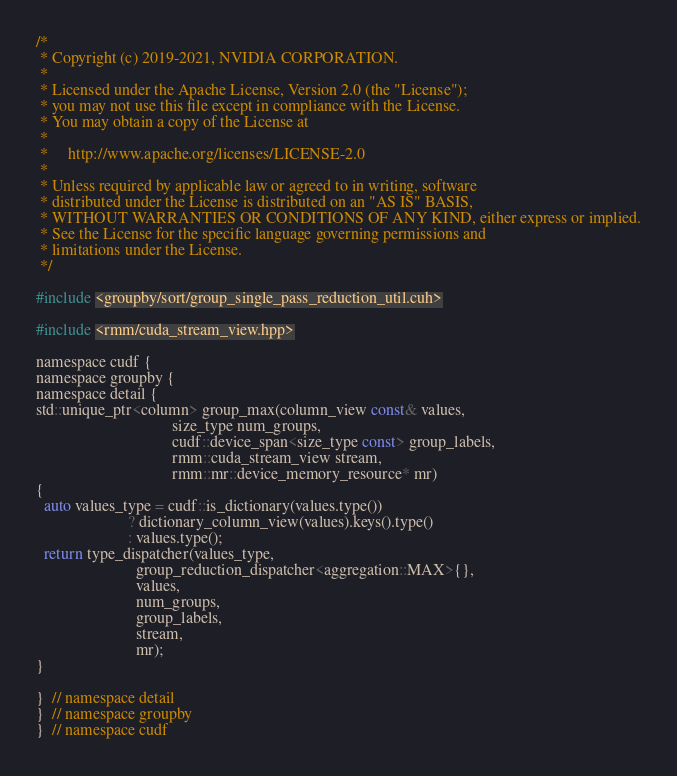Convert code to text. <code><loc_0><loc_0><loc_500><loc_500><_Cuda_>/*
 * Copyright (c) 2019-2021, NVIDIA CORPORATION.
 *
 * Licensed under the Apache License, Version 2.0 (the "License");
 * you may not use this file except in compliance with the License.
 * You may obtain a copy of the License at
 *
 *     http://www.apache.org/licenses/LICENSE-2.0
 *
 * Unless required by applicable law or agreed to in writing, software
 * distributed under the License is distributed on an "AS IS" BASIS,
 * WITHOUT WARRANTIES OR CONDITIONS OF ANY KIND, either express or implied.
 * See the License for the specific language governing permissions and
 * limitations under the License.
 */

#include <groupby/sort/group_single_pass_reduction_util.cuh>

#include <rmm/cuda_stream_view.hpp>

namespace cudf {
namespace groupby {
namespace detail {
std::unique_ptr<column> group_max(column_view const& values,
                                  size_type num_groups,
                                  cudf::device_span<size_type const> group_labels,
                                  rmm::cuda_stream_view stream,
                                  rmm::mr::device_memory_resource* mr)
{
  auto values_type = cudf::is_dictionary(values.type())
                       ? dictionary_column_view(values).keys().type()
                       : values.type();
  return type_dispatcher(values_type,
                         group_reduction_dispatcher<aggregation::MAX>{},
                         values,
                         num_groups,
                         group_labels,
                         stream,
                         mr);
}

}  // namespace detail
}  // namespace groupby
}  // namespace cudf
</code> 